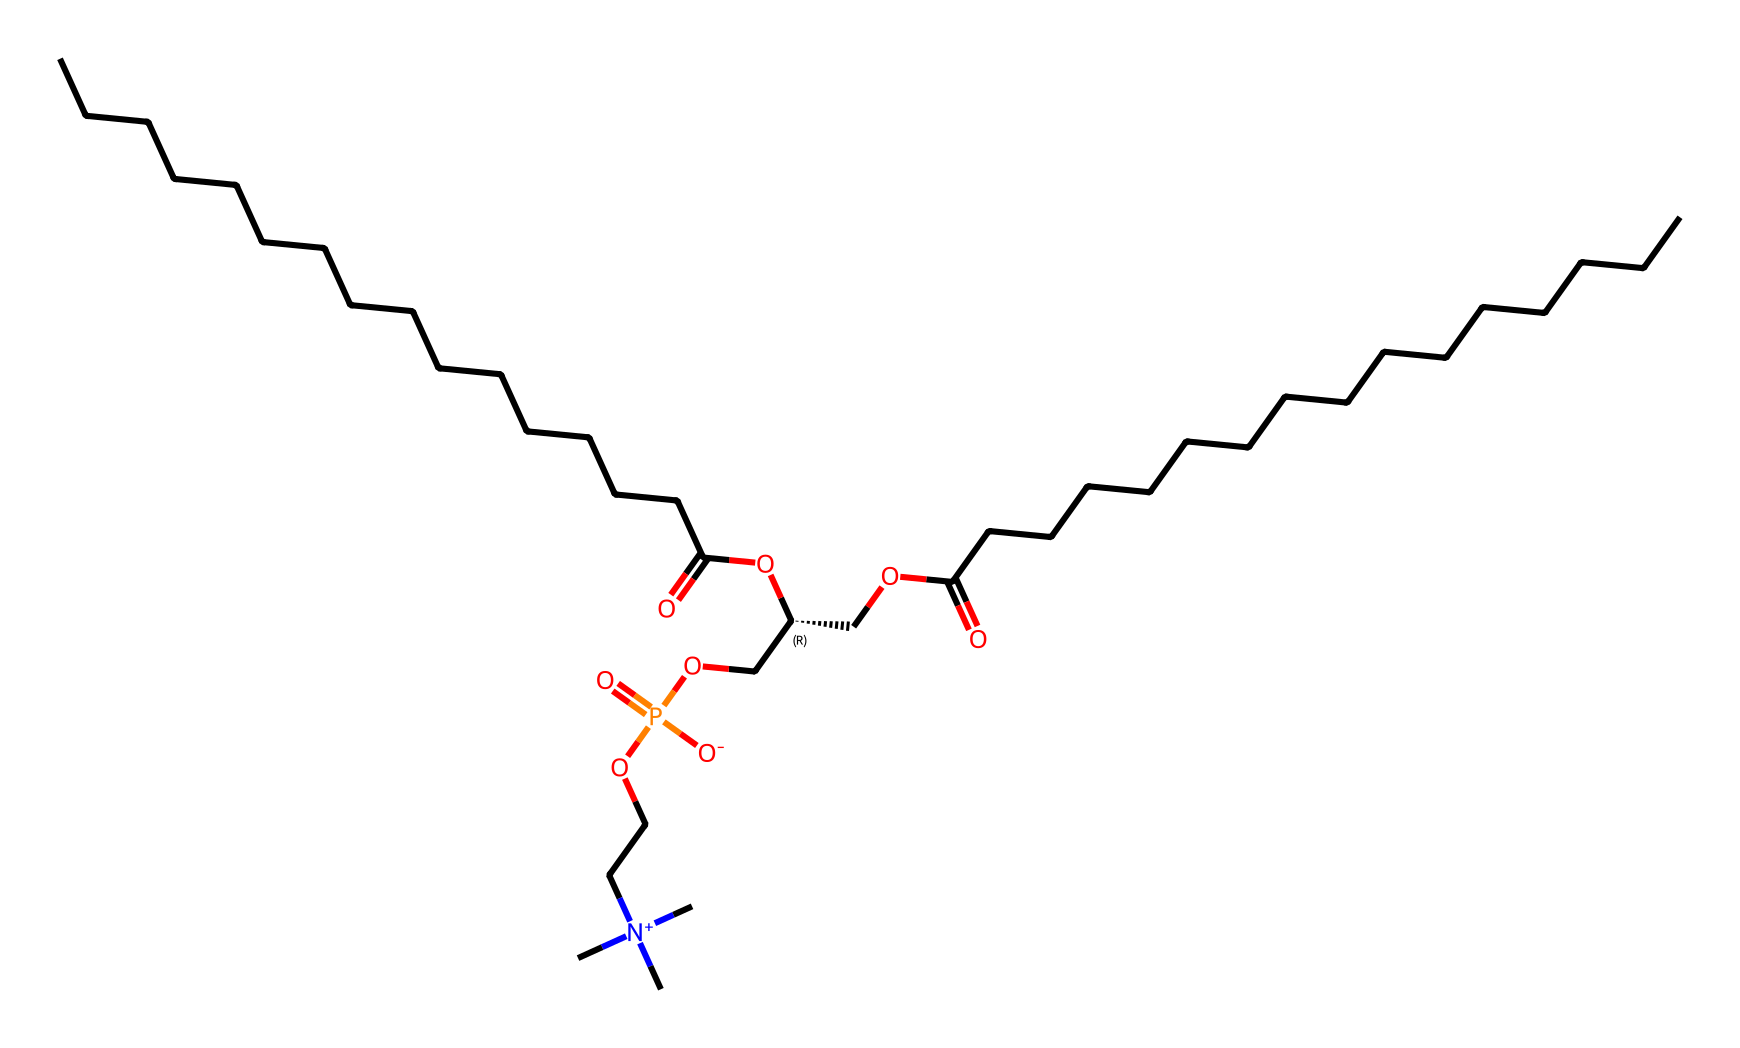What is the main functional group in this structure? The structure contains a phosphate group (P=O) and its surrounding O atoms, which is characteristic of phosphatidylcholine.
Answer: phosphate group How many carbon atoms are present in this compound? By examining the linear segments in the SMILES representation, there are 30 carbon atoms listed from the long alkyl chains, both at the beginning and the end of the molecule.
Answer: 30 What type of bond connects the phosphate group to the glycerol moiety? The phosphate group is esterified to the glycerol via an ester bond, marked by the presence of a carbon oxygen bond linking the glycerol's oxygen to the phosphorus.
Answer: ester bond What is the overall charge of the nitrogen atom in this molecule? The nitrogen atom in the structure has a quaternary ammonium designation (N+), indicating it carries a positive charge due to four bonds.
Answer: positive What are the two main components of phosphatidylcholine? Phosphatidylcholine is composed of a glycerol backbone esterified to fatty acids and a phosphate group with a choline molecule attached.
Answer: glycerol and phosphate What role does phosphatidylcholine play in biological membranes? This compound is a key phospholipid that helps form lipid bilayers, crucial for cell membrane structure and function due to its amphipathic properties.
Answer: cell membrane structure 